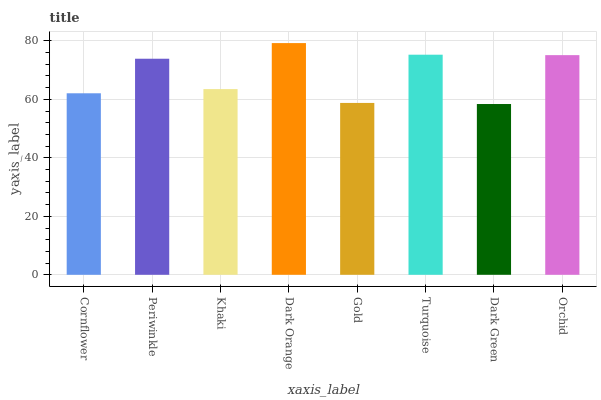Is Periwinkle the minimum?
Answer yes or no. No. Is Periwinkle the maximum?
Answer yes or no. No. Is Periwinkle greater than Cornflower?
Answer yes or no. Yes. Is Cornflower less than Periwinkle?
Answer yes or no. Yes. Is Cornflower greater than Periwinkle?
Answer yes or no. No. Is Periwinkle less than Cornflower?
Answer yes or no. No. Is Periwinkle the high median?
Answer yes or no. Yes. Is Khaki the low median?
Answer yes or no. Yes. Is Cornflower the high median?
Answer yes or no. No. Is Turquoise the low median?
Answer yes or no. No. 